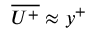Convert formula to latex. <formula><loc_0><loc_0><loc_500><loc_500>\overline { { U ^ { + } } } \approx y ^ { + }</formula> 